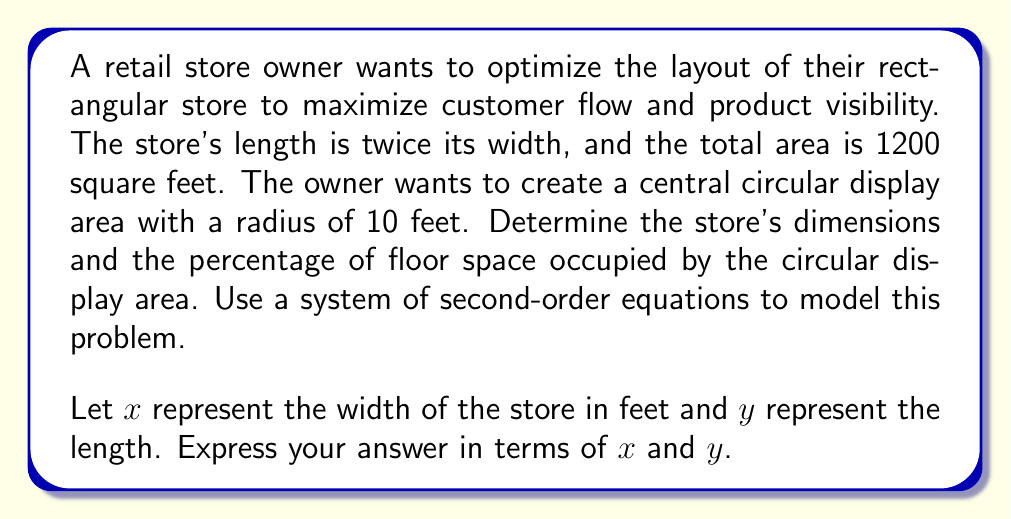Can you solve this math problem? To solve this problem, we'll use a system of second-order equations:

1. Area equation: $xy = 1200$ (total store area)
2. Length-width relationship: $y = 2x$ (length is twice the width)

Substituting equation 2 into equation 1:
$x(2x) = 1200$
$2x^2 = 1200$
$x^2 = 600$
$x = \sqrt{600} = 10\sqrt{6} \approx 24.49$ feet

Now we can calculate $y$:
$y = 2x = 2(10\sqrt{6}) = 20\sqrt{6} \approx 48.99$ feet

To find the percentage of floor space occupied by the circular display:

Area of circular display: $A_c = \pi r^2 = \pi (10^2) = 100\pi$ sq ft

Percentage of floor space:
$$\text{Percentage} = \frac{\text{Display Area}}{\text{Total Area}} \times 100\% = \frac{100\pi}{1200} \times 100\% \approx 26.18\%$$

This system of second-order equations allows us to efficiently determine the optimal store layout, balancing the rectangular shape of the store with the circular display area.
Answer: Store dimensions: Width ($x$) = $10\sqrt{6}$ feet, Length ($y$) = $20\sqrt{6}$ feet
Percentage of floor space occupied by circular display: $\frac{100\pi}{1200} \times 100\% \approx 26.18\%$ 